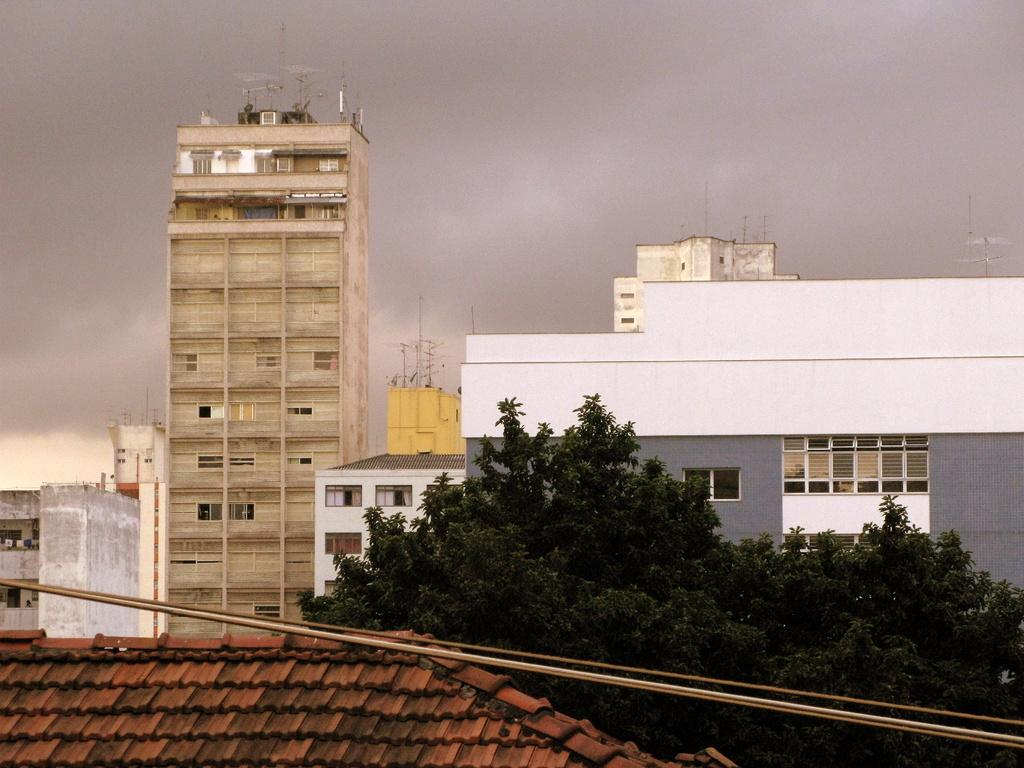What type of structures can be seen in the image? There are buildings in the image. Are there any specific features on the buildings? Yes, there are poles on some of the buildings. What other tall structure is present in the image? There is a tower in the image. What type of vegetation can be seen in the image? There are trees in the image. What is visible in the sky in the image? There are clouds in the sky. What type of cork can be seen floating in the image? There is no cork present in the image. Can you tell me how many fathers are visible in the image? There is no reference to a father or any people in the image, so it cannot be determined from the image. 